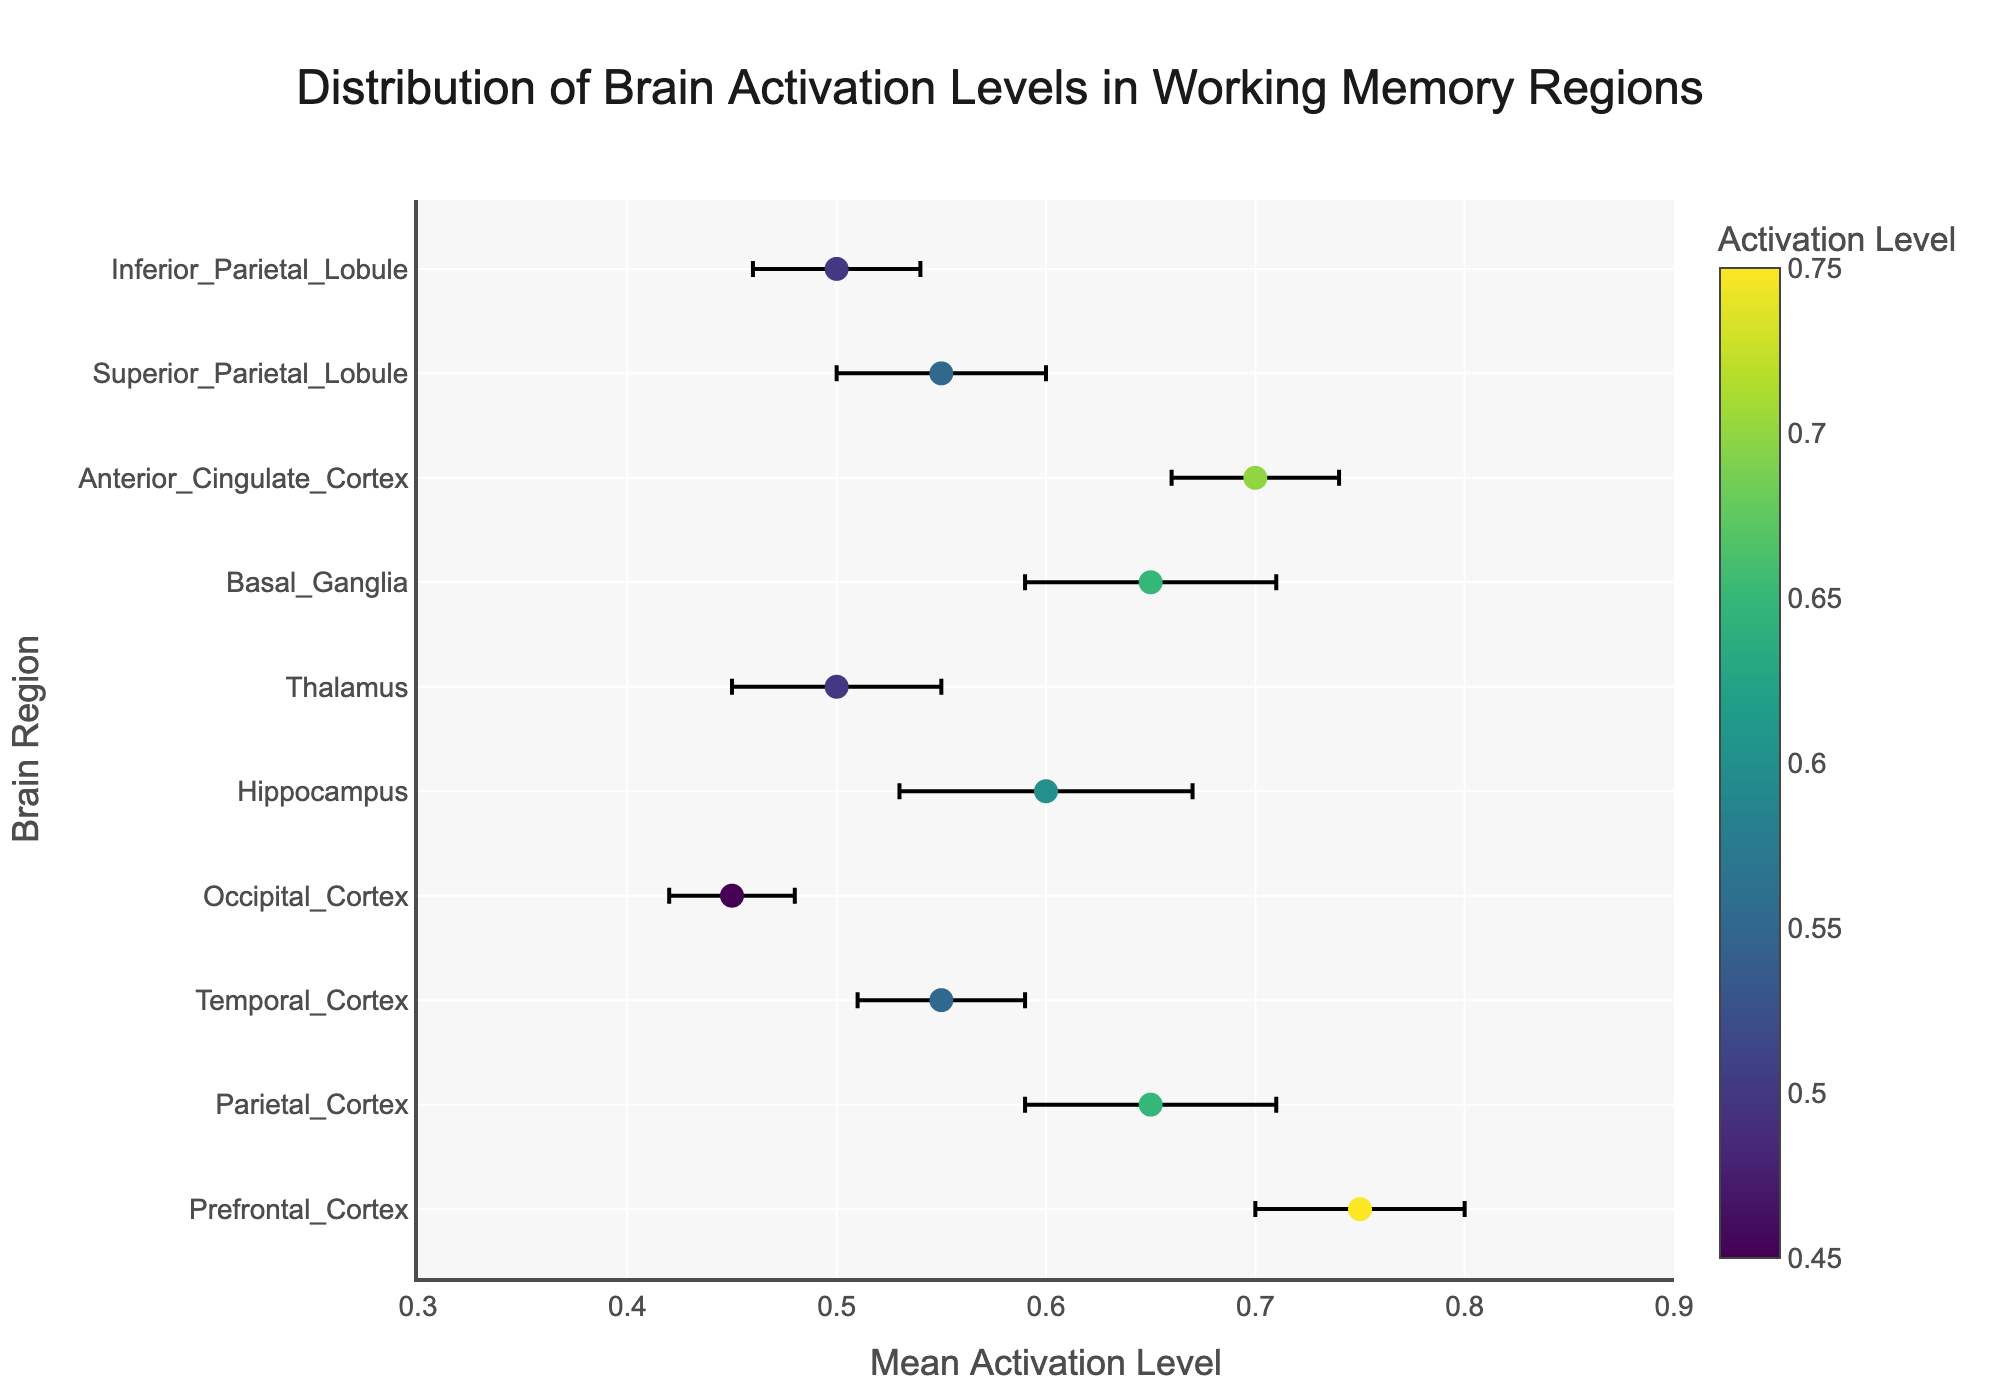What's the title of the figure? The title is located at the top center of the figure, with large bold text.
Answer: Distribution of Brain Activation Levels in Working Memory Regions What's the mean activation level of the Prefrontal Cortex? Locate the Prefrontal Cortex on the y-axis and read the corresponding mean activation level on the x-axis.
Answer: 0.75 Which brain region has the highest mean activation level? Look at the farthest right dot on the x-axis to determine the brain region with the highest value.
Answer: Prefrontal Cortex What is the error bar range for the Temporal Cortex? Find the dot for the Temporal Cortex, note the mean activation level and the standard error, then calculate the range as [mean - SE, mean + SE].
Answer: [0.51, 0.59] Which brain regions have a mean activation level of 0.65? Identify dots at 0.65 on the x-axis and find the corresponding regions on the y-axis.
Answer: Parietal Cortex, Basal Ganglia What's the difference in mean activation levels between the Occipital Cortex and the Anterior Cingulate Cortex? Subtract the mean activation level of the Occipital Cortex from that of the Anterior Cingulate Cortex.
Answer: 0.25 How many brain regions are shown in the figure? Count the total number of dots (or unique entries on the y-axis).
Answer: 10 Which brain region has the smallest standard error? Look for the shortest error bar in the figure.
Answer: Occipital Cortex What is the color scale indicating in the figure? The color scale is a continuous gradient shown next to the plot, indicating the activation level.
Answer: Activation Level 